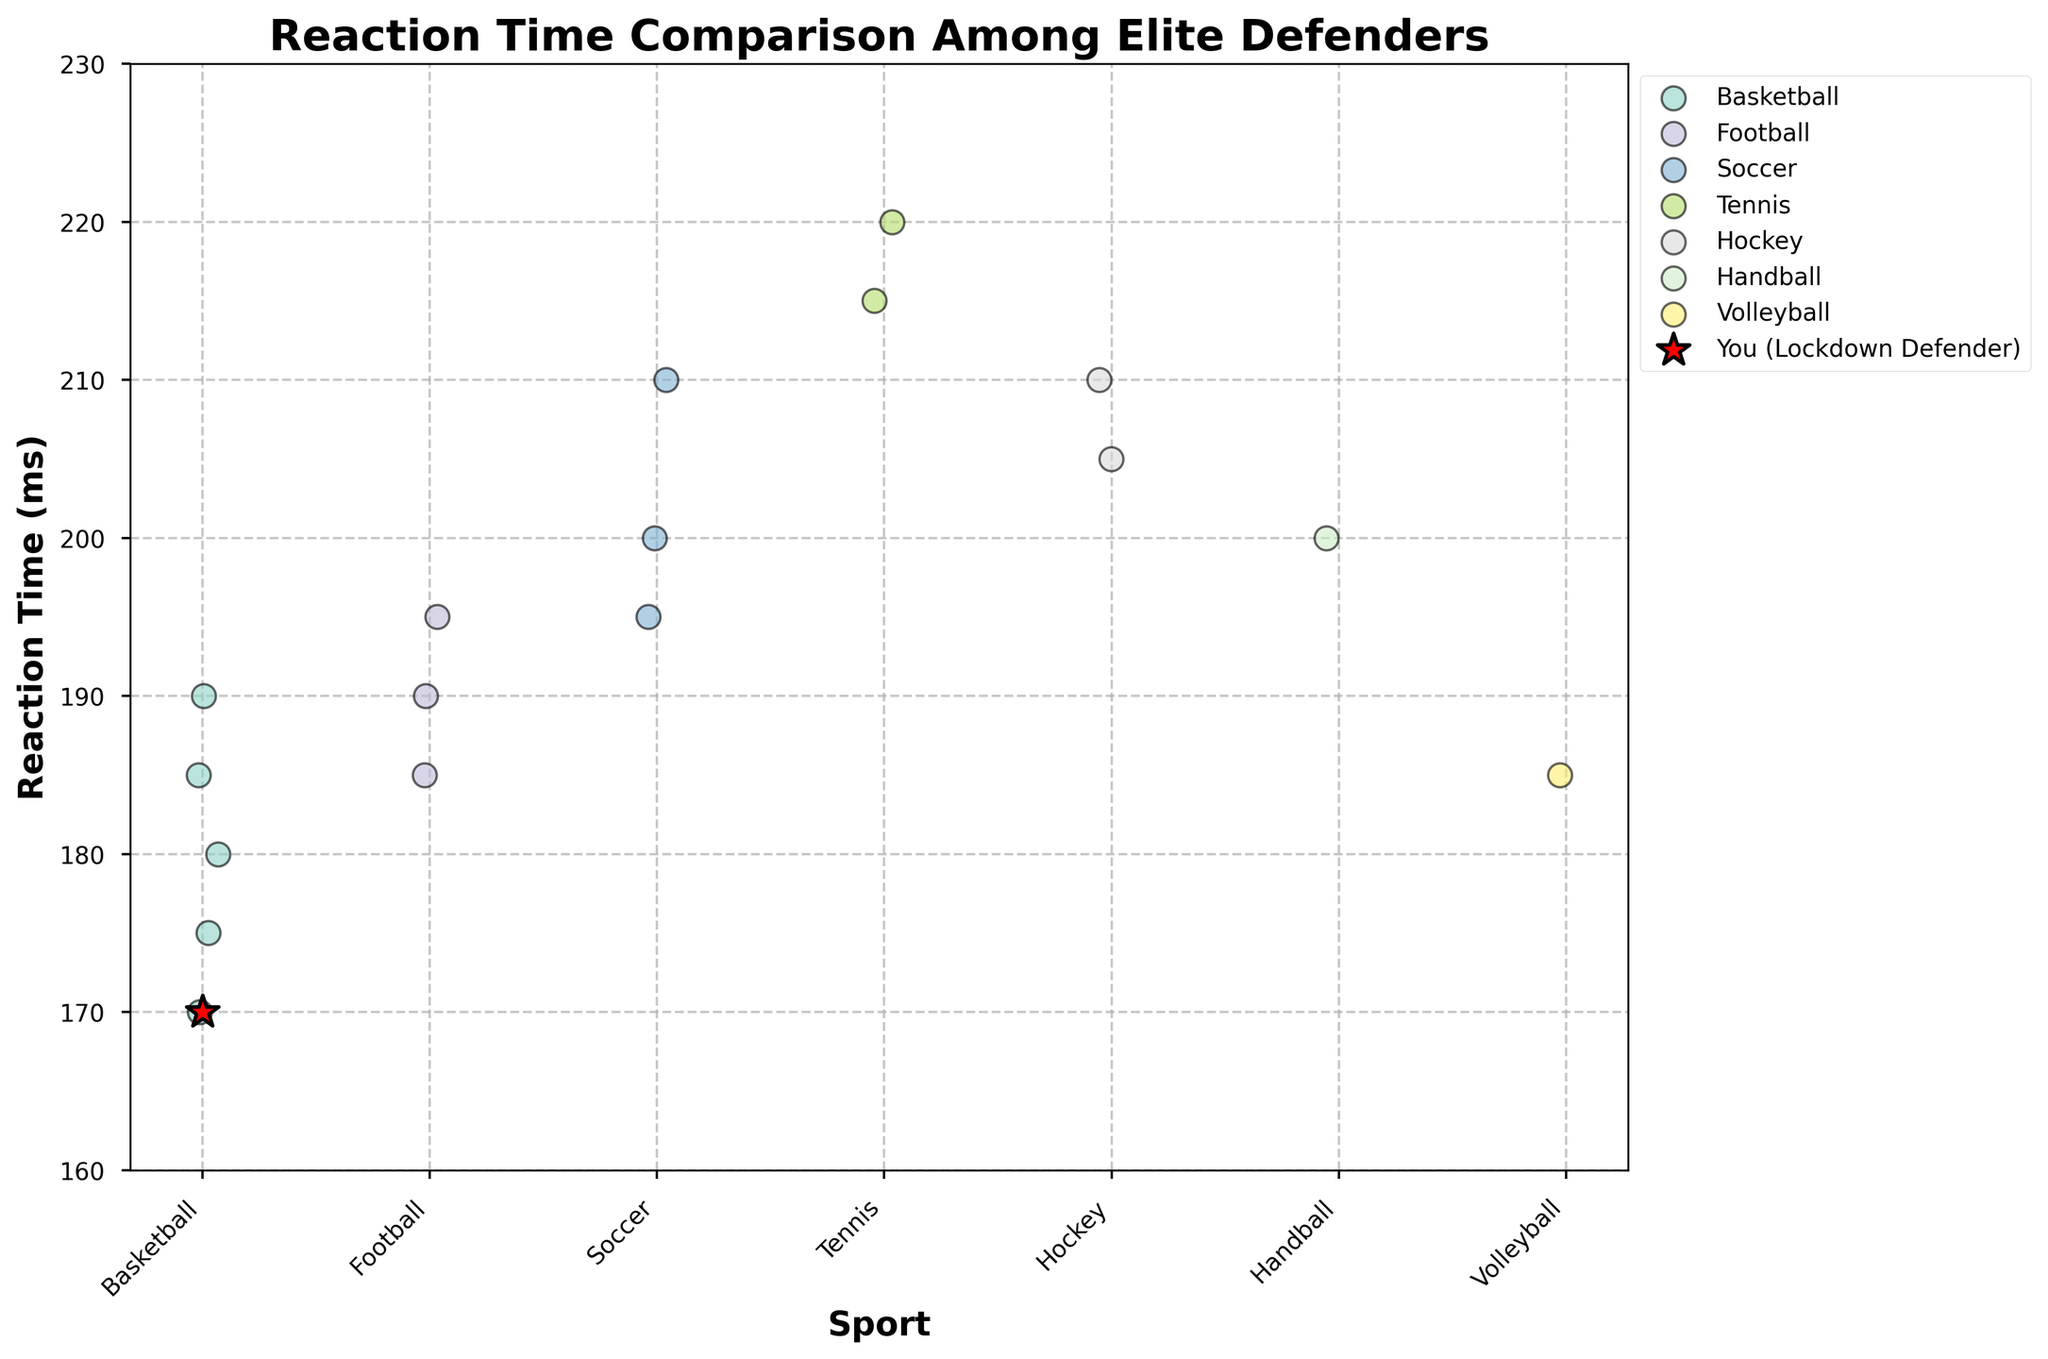What's the title of the figure? The title is located at the top of the figure and is often intended to give a quick overview of what the figure is about. In this case, it should summarize the key insight.
Answer: Reaction Time Comparison Among Elite Defenders What are the x-axis labels in the figure? The x-axis labels are positioned at the bottom of the figure and represent different categories of data being compared. In this case, the labels correspond to different sports.
Answer: Basketball, Football, Soccer, Tennis, Hockey, Handball, Volleyball Identify the marker that represents "You" on the plot? The markers in the plot use different shapes and colors to represent different data points. According to the code, the marker for "You" is a star (*) in red color.
Answer: Red star (*) Which sport has athletes with the lowest reaction time? To find this information, look at the spread of data points for each sport. Identify which sport's data points have the lowest minimum reaction time value. Here, Basketball has athletes with the lowest reaction time values.
Answer: Basketball Who has the highest reaction time among the athletes? Look at the vertical position of each data point and identify which one is the highest. In this case, the highest reaction time is indicated by the top-most data point on the plot.
Answer: Novak Djokovic What's the range of reaction times for Volleyball players? To find the range, identify the highest and lowest reaction time values for Volleyball players. According to the plot, Volleyball players have only one data point at 185 ms, so the range is 0 ms.
Answer: 0 ms What is the median reaction time for Football players? To find the median, list the reaction times for Football players (195, 185, 190) and arrange them in ascending order: 185, 190, 195. The middle value is 190.
Answer: 190 ms Compare the reaction time of Sergio Ramos and N'Golo Kanté. Who is faster? Compare the vertical positions of the data points for Sergio Ramos and N'Golo Kanté. The lower the point, the faster the reaction time. Sergio Ramos has a reaction time of 210 ms, while N'Golo Kanté has 195 ms, meaning N'Golo Kanté is faster.
Answer: N'Golo Kanté Which sport shows the most variability in reaction times? Variability can be observed by looking at the spread of the data points for each sport. Tennis has the most spread data points (220 and 215 ms), indicating the highest variability.
Answer: Tennis Which sport has the closest reaction times among its athletes? This can be determined by looking at how closely clustered the data points are for each sport. Volleyball, having only one data point at 185 ms, essentially has no variability. Among sports with more than one data point, Basketball shows close reaction times between its athletes (170, 175, 180, 185, and 190 ms).
Answer: Volleyball 